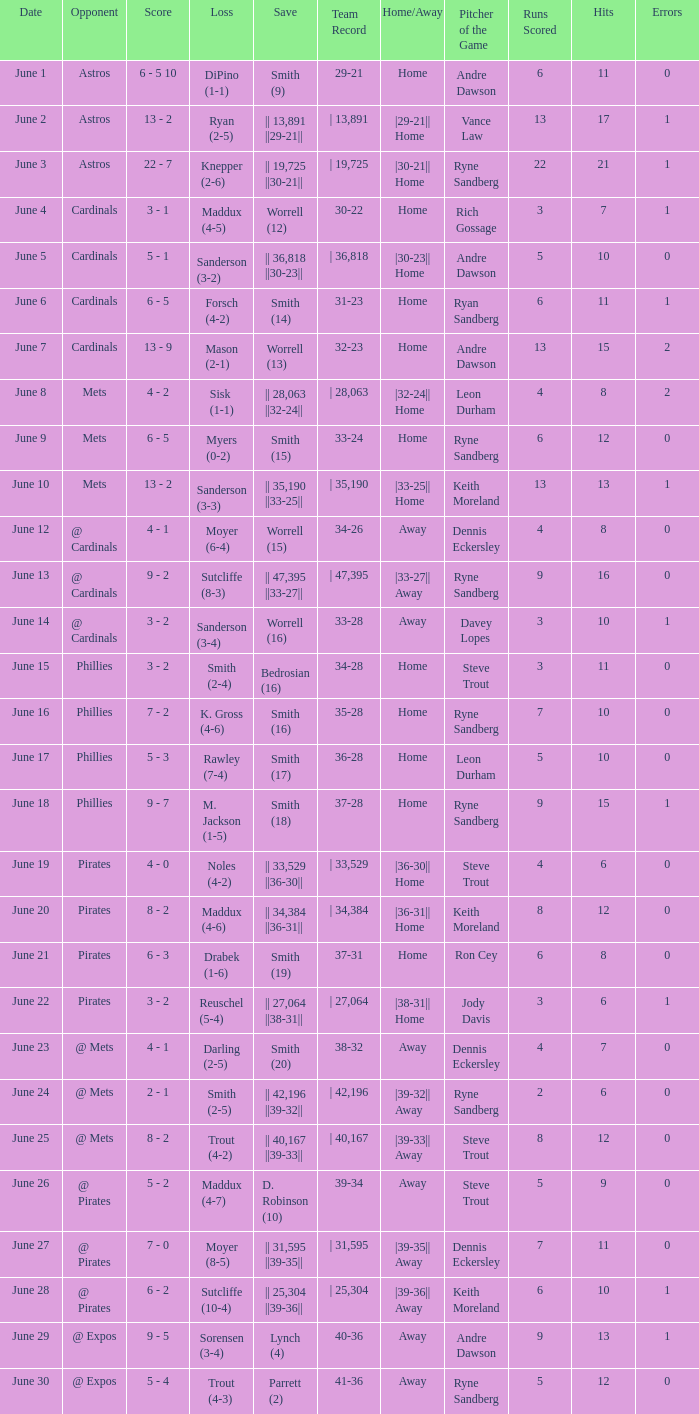On which date did the game featuring sutcliffe's 10-4 defeat occur? June 28. 